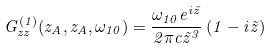<formula> <loc_0><loc_0><loc_500><loc_500>G _ { z z } ^ { ( 1 ) } ( z _ { A } , z _ { A } , \omega _ { 1 0 } ) = \frac { \omega _ { 1 0 } e ^ { i \tilde { z } } } { 2 \pi c \tilde { z } ^ { 3 } } \left ( 1 - i \tilde { z } \right )</formula> 